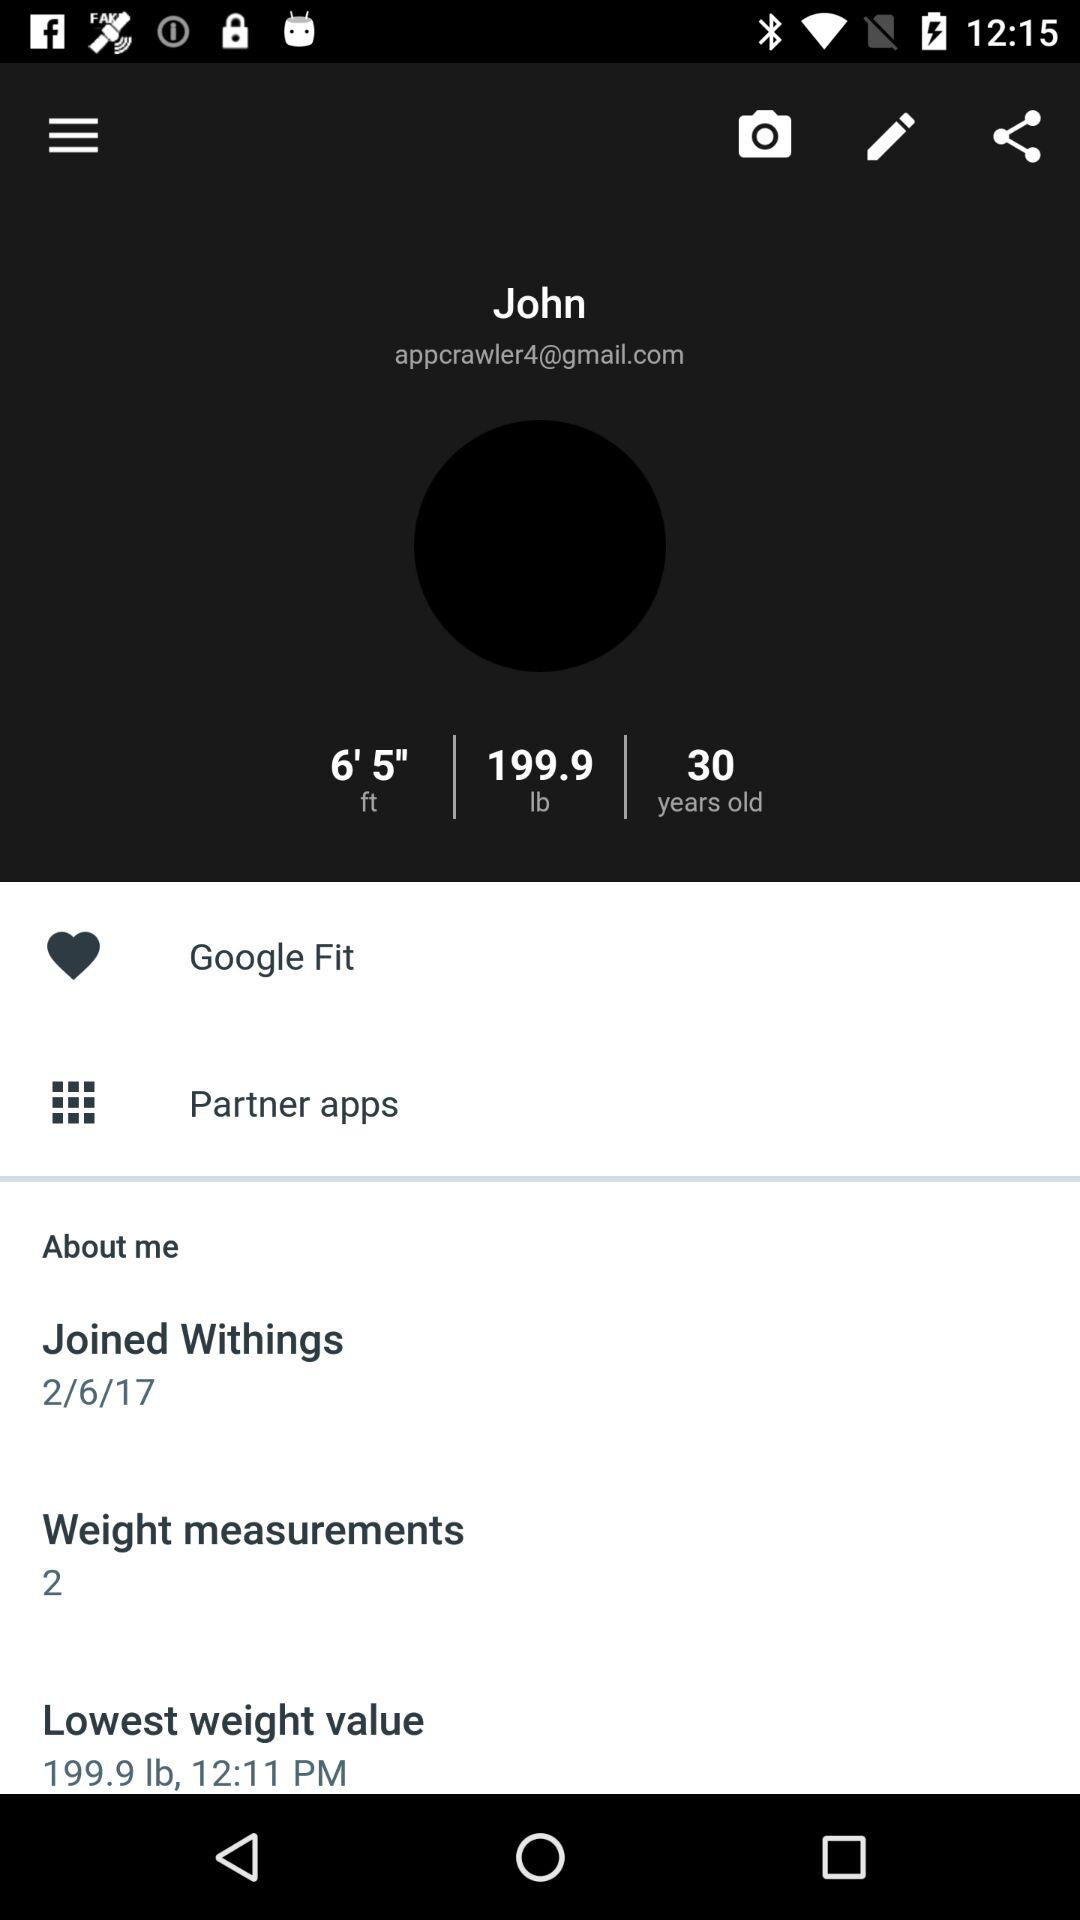What is the height of John? John's height is 6' 5" ft. 